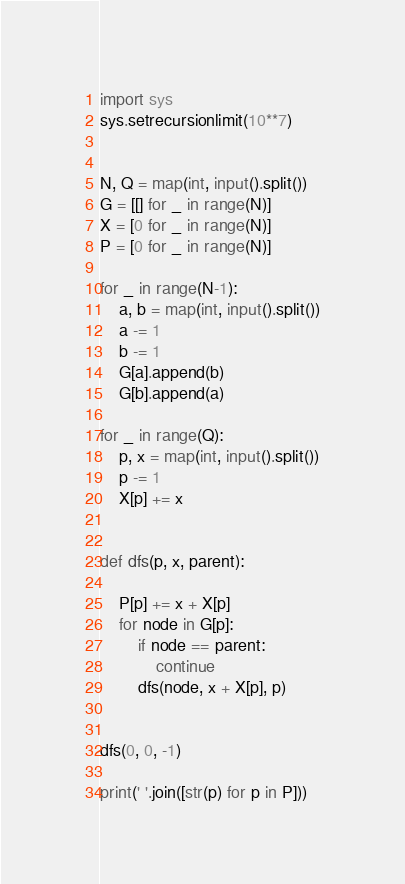Convert code to text. <code><loc_0><loc_0><loc_500><loc_500><_Python_>import sys
sys.setrecursionlimit(10**7)


N, Q = map(int, input().split())
G = [[] for _ in range(N)]
X = [0 for _ in range(N)]
P = [0 for _ in range(N)]

for _ in range(N-1):
    a, b = map(int, input().split())
    a -= 1
    b -= 1
    G[a].append(b)
    G[b].append(a)

for _ in range(Q):
    p, x = map(int, input().split())
    p -= 1
    X[p] += x


def dfs(p, x, parent):

    P[p] += x + X[p]
    for node in G[p]:
        if node == parent:
            continue
        dfs(node, x + X[p], p)


dfs(0, 0, -1)

print(' '.join([str(p) for p in P]))
</code> 